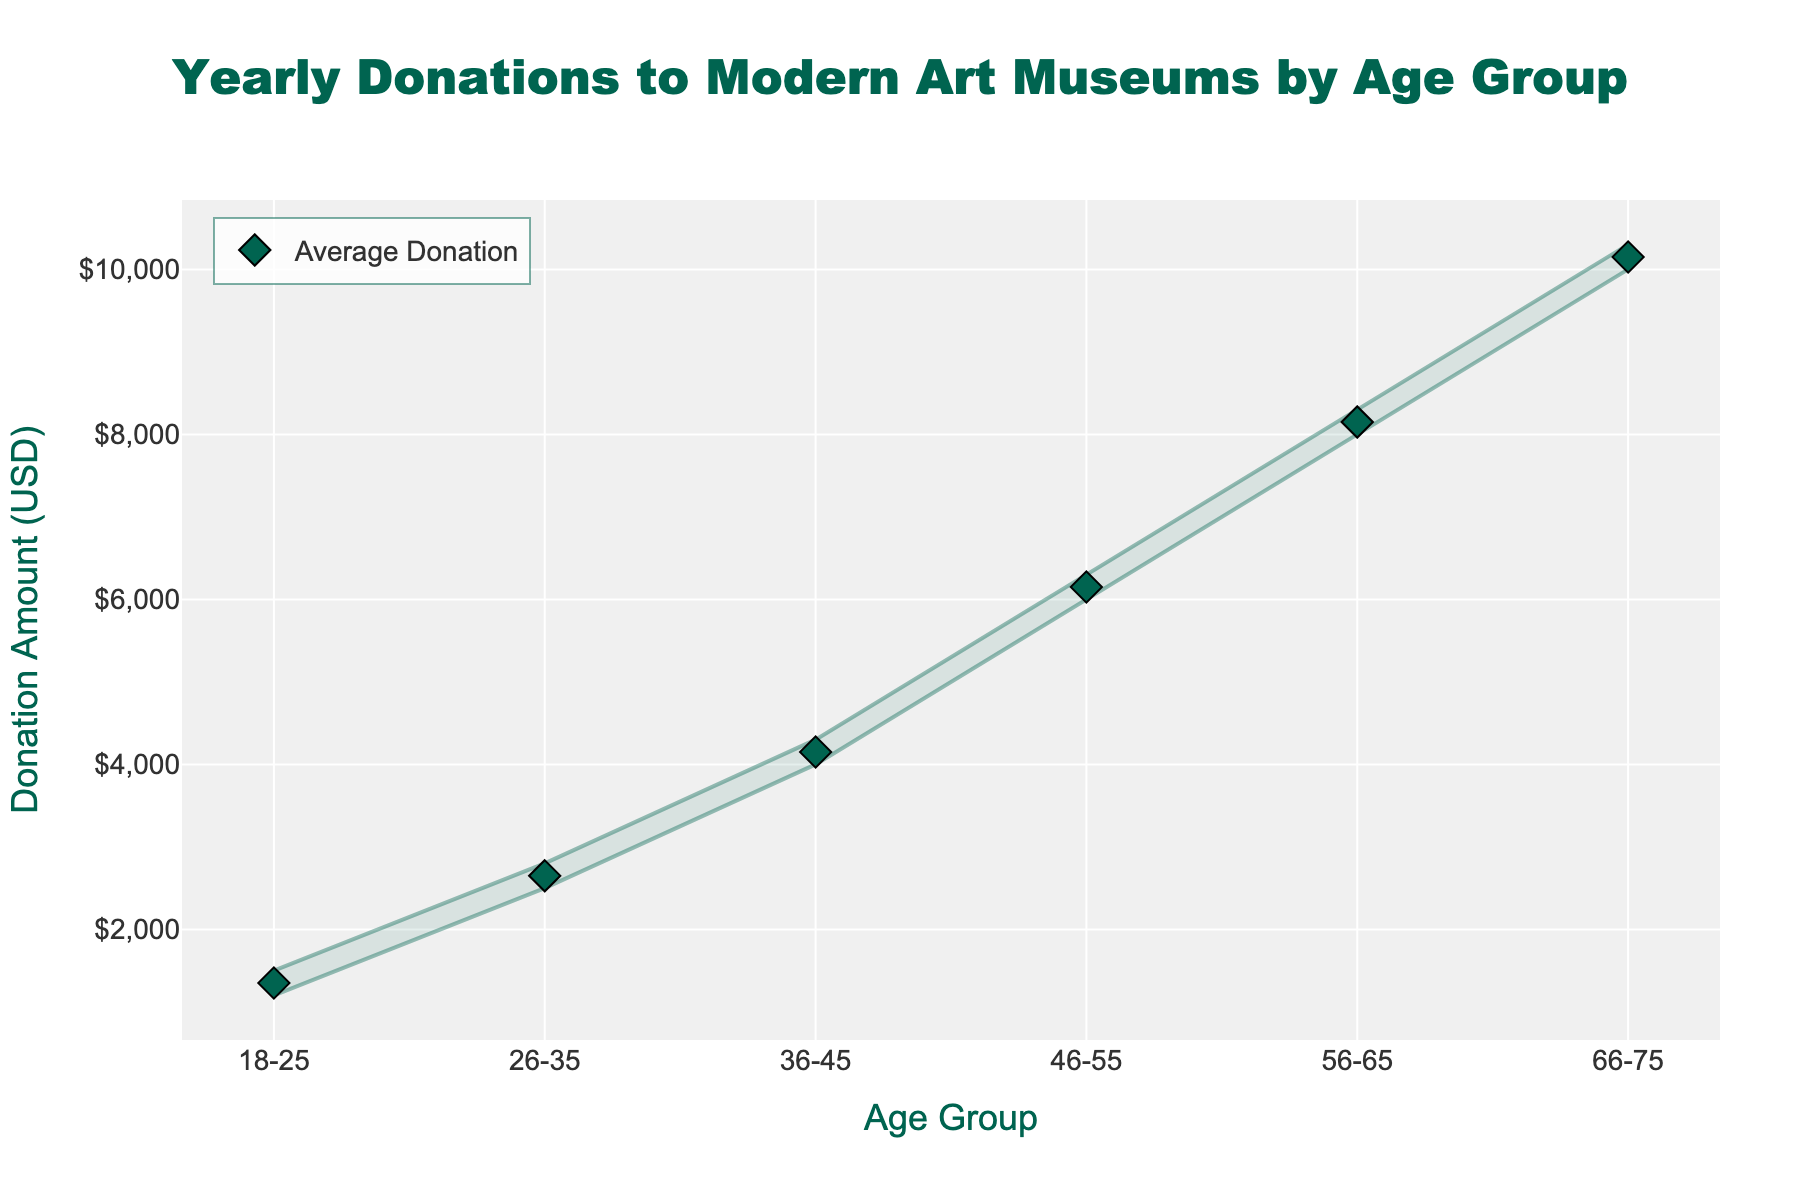What is the title of the figure? The title is usually displayed prominently at the top of the figure, describing its content.
Answer: Yearly Donations to Modern Art Museums by Age Group Which age group has the highest average yearly donation? To find this, look for the group with the highest mean donation amount, usually indicated by the highest diamond marker.
Answer: 66-75 What is the range of donations for the age group 36-45? The range is determined by the minimum and maximum donation amounts for that age group, represented by the lines on the plot.
Answer: $4000 to $4300 How does the mean yearly donation amount for the 26-35 age group compare to the mean for the 46-55 age group? Locate the diamond markers for these age groups and compare their positions on the vertical axis.
Answer: $2650 vs. $6150 Which age group has the smallest range of yearly donations? Find the age group with the shortest distance between the minimum and maximum donation lines.
Answer: 18-25 What is the minimum yearly donation amount for the age group 56-65? Look for the lowest point on the vertical axis for that age group.
Answer: $8000 How much more is the highest donation in the 46-55 age group compared to the highest donation in the 18-25 age group? Calculate the difference between the highest points of these age groups. $6300 - $1500 = $4800
Answer: $4800 Which age group has the most consistently high donations? Determine which age group has the narrowest range and the highest mean donation.
Answer: 66-75 Are any age groups' mean donations equal to their maximum donation amounts? Check if the diamond marker (mean) coincides with the top end of the range line (maximum) for any age group.
Answer: No What is the average donation amount for the age group with the widest range of donations? Identify the age group with the largest difference between min and max, then locate its mean donation amount.
Answer: $6150 